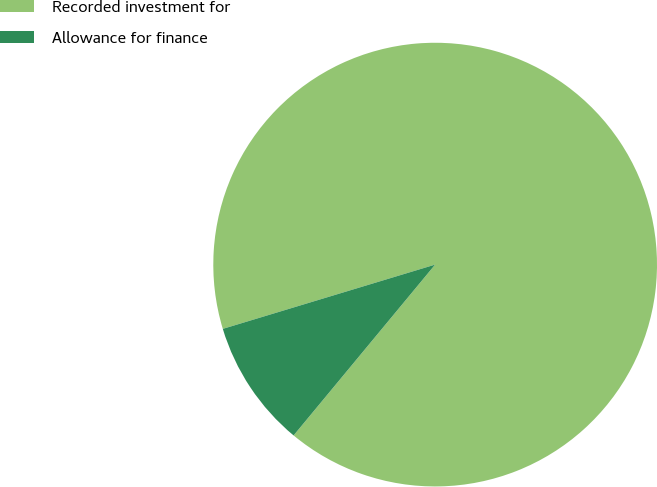Convert chart to OTSL. <chart><loc_0><loc_0><loc_500><loc_500><pie_chart><fcel>Recorded investment for<fcel>Allowance for finance<nl><fcel>90.69%<fcel>9.31%<nl></chart> 